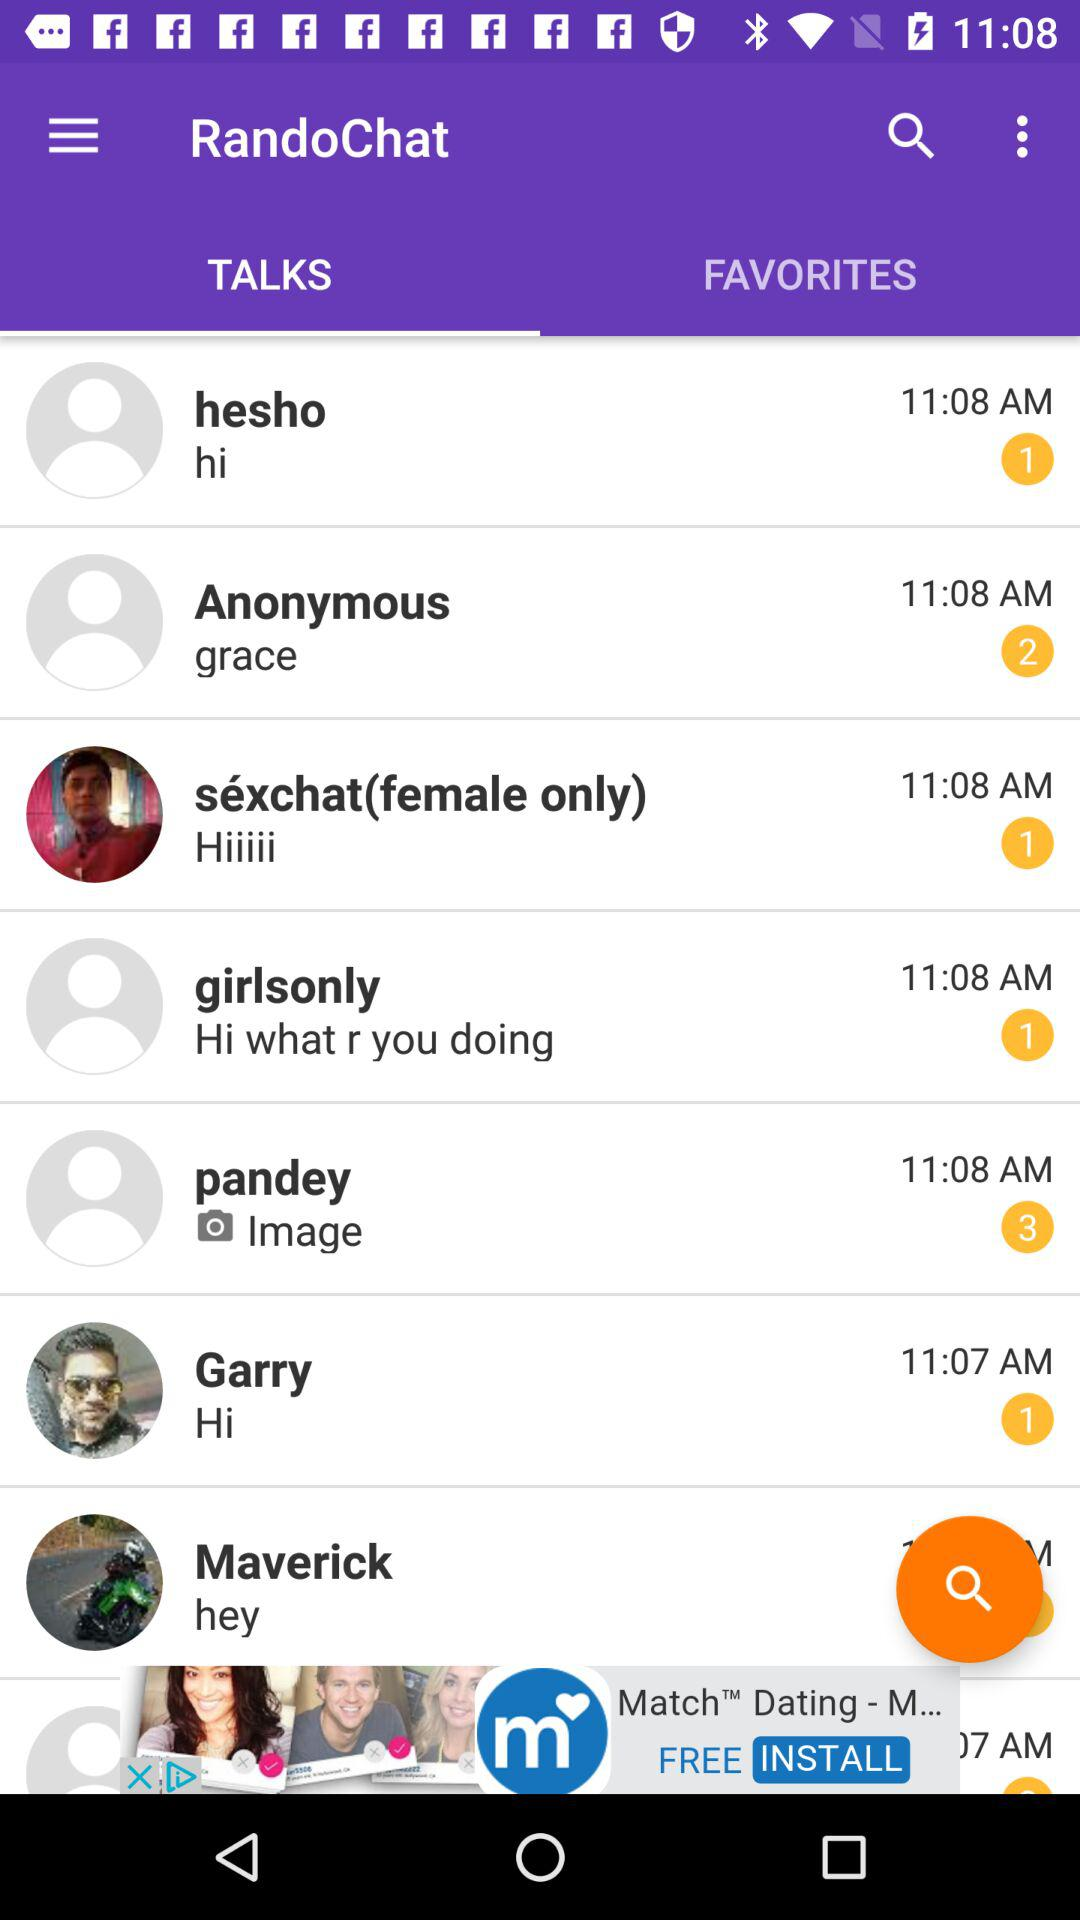How many messages are received from Garry? The number of messages received from Garry is 1. 